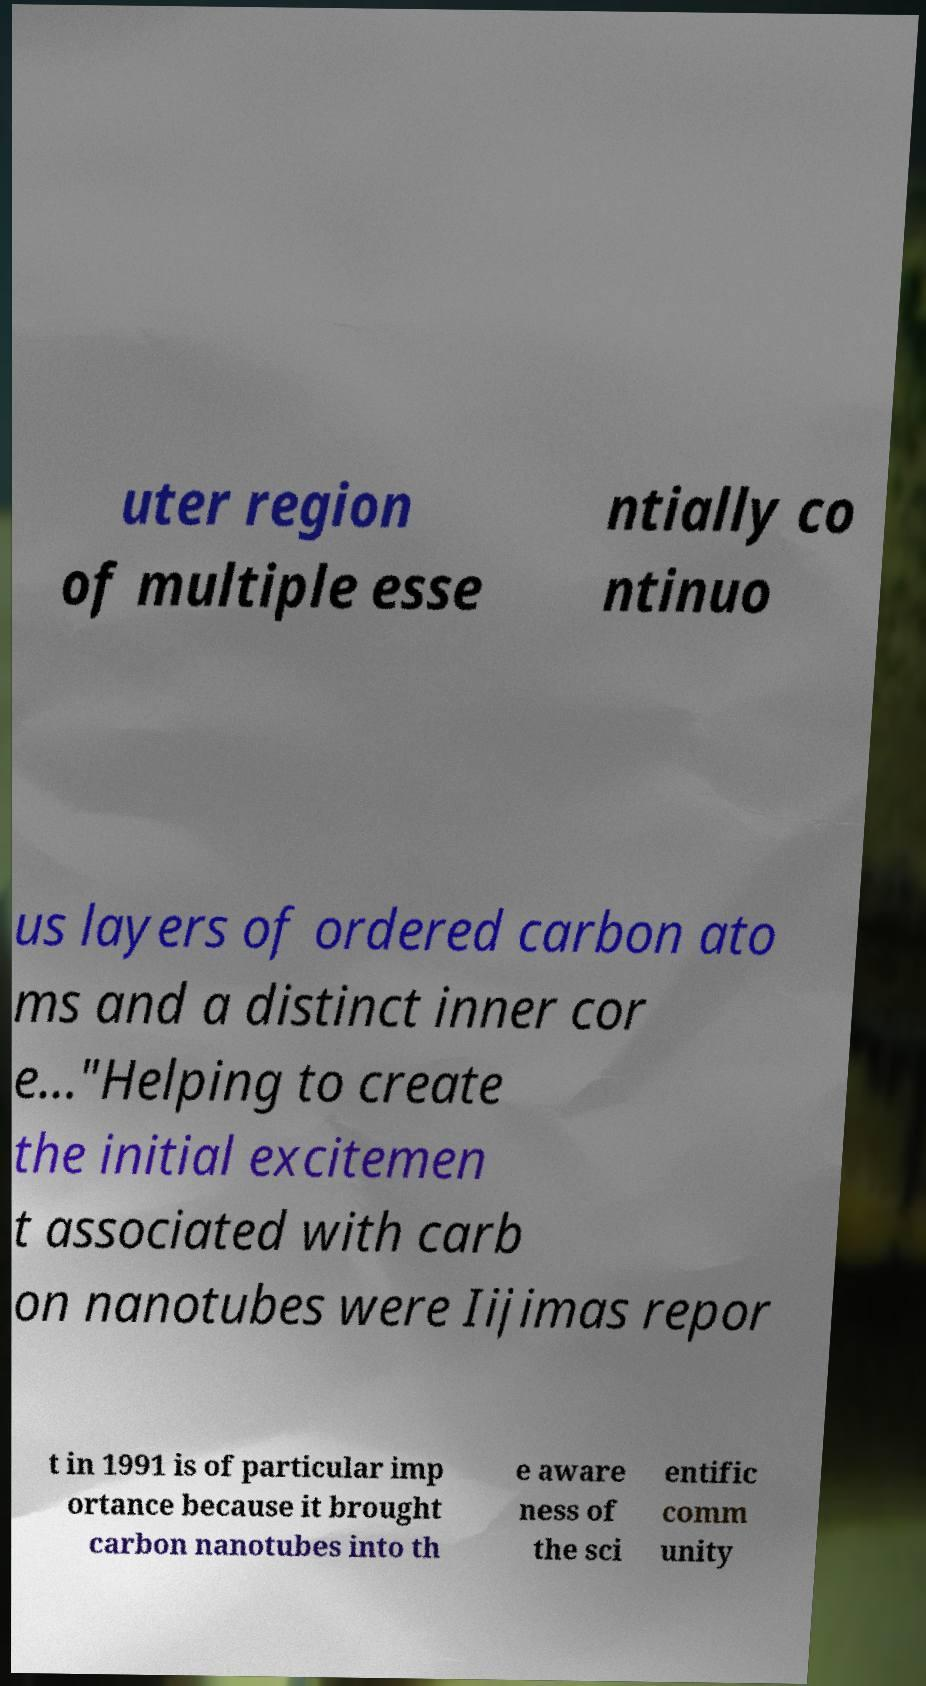There's text embedded in this image that I need extracted. Can you transcribe it verbatim? uter region of multiple esse ntially co ntinuo us layers of ordered carbon ato ms and a distinct inner cor e..."Helping to create the initial excitemen t associated with carb on nanotubes were Iijimas repor t in 1991 is of particular imp ortance because it brought carbon nanotubes into th e aware ness of the sci entific comm unity 